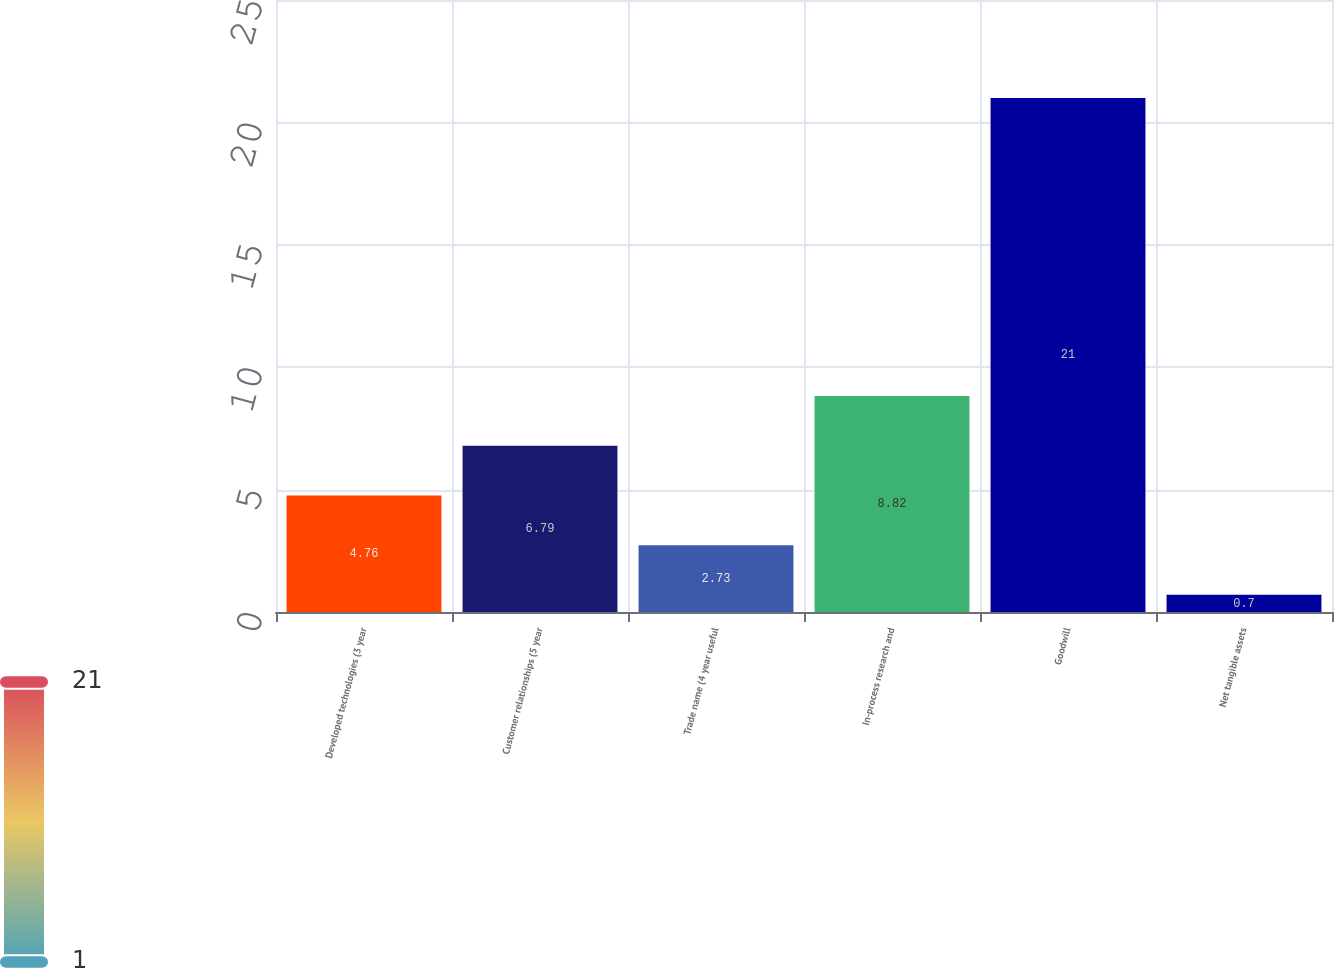Convert chart to OTSL. <chart><loc_0><loc_0><loc_500><loc_500><bar_chart><fcel>Developed technologies (3 year<fcel>Customer relationships (5 year<fcel>Trade name (4 year useful<fcel>In-process research and<fcel>Goodwill<fcel>Net tangible assets<nl><fcel>4.76<fcel>6.79<fcel>2.73<fcel>8.82<fcel>21<fcel>0.7<nl></chart> 